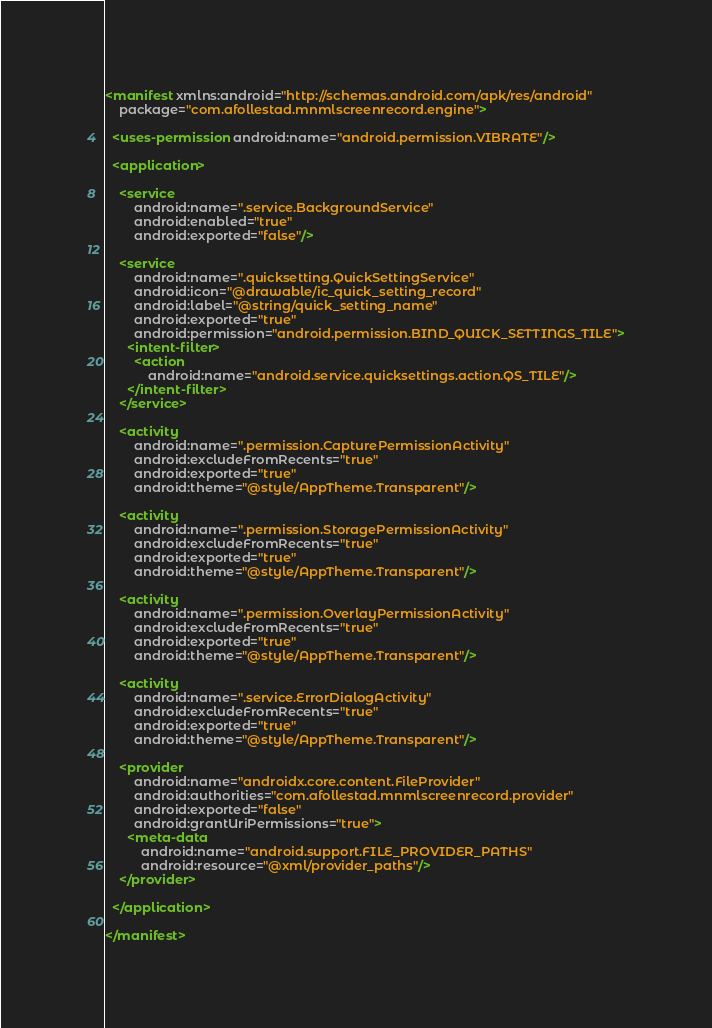<code> <loc_0><loc_0><loc_500><loc_500><_XML_><manifest xmlns:android="http://schemas.android.com/apk/res/android"
    package="com.afollestad.mnmlscreenrecord.engine">

  <uses-permission android:name="android.permission.VIBRATE"/>

  <application>

    <service
        android:name=".service.BackgroundService"
        android:enabled="true"
        android:exported="false"/>

    <service
        android:name=".quicksetting.QuickSettingService"
        android:icon="@drawable/ic_quick_setting_record"
        android:label="@string/quick_setting_name"
        android:exported="true"
        android:permission="android.permission.BIND_QUICK_SETTINGS_TILE">
      <intent-filter>
        <action
            android:name="android.service.quicksettings.action.QS_TILE"/>
      </intent-filter>
    </service>

    <activity
        android:name=".permission.CapturePermissionActivity"
        android:excludeFromRecents="true"
        android:exported="true"
        android:theme="@style/AppTheme.Transparent"/>

    <activity
        android:name=".permission.StoragePermissionActivity"
        android:excludeFromRecents="true"
        android:exported="true"
        android:theme="@style/AppTheme.Transparent"/>

    <activity
        android:name=".permission.OverlayPermissionActivity"
        android:excludeFromRecents="true"
        android:exported="true"
        android:theme="@style/AppTheme.Transparent"/>

    <activity
        android:name=".service.ErrorDialogActivity"
        android:excludeFromRecents="true"
        android:exported="true"
        android:theme="@style/AppTheme.Transparent"/>

    <provider
        android:name="androidx.core.content.FileProvider"
        android:authorities="com.afollestad.mnmlscreenrecord.provider"
        android:exported="false"
        android:grantUriPermissions="true">
      <meta-data
          android:name="android.support.FILE_PROVIDER_PATHS"
          android:resource="@xml/provider_paths"/>
    </provider>

  </application>

</manifest>
</code> 